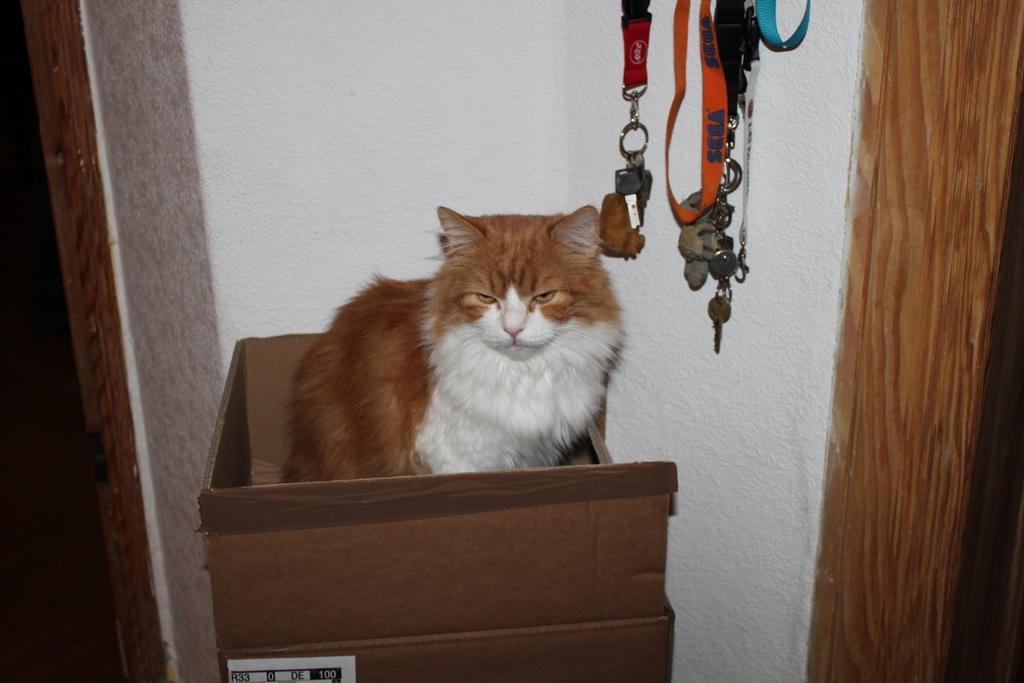How would you summarize this image in a sentence or two? In the foreground of this image, there is a cat and it seems like sitting in a cardboard. In the background, there is a wall and few ID tags and chains are hanging. 